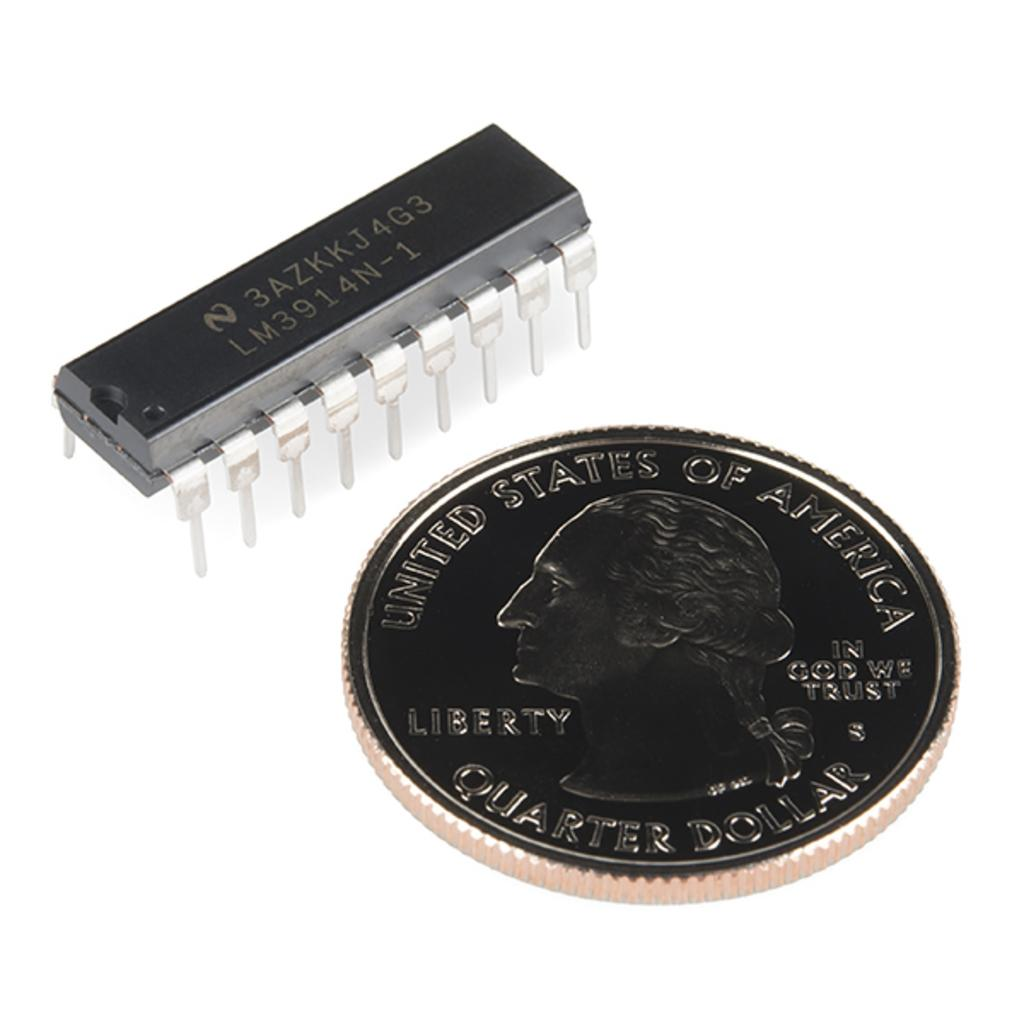<image>
Offer a succinct explanation of the picture presented. A uninted states quarter dollar next to an electrical component. 